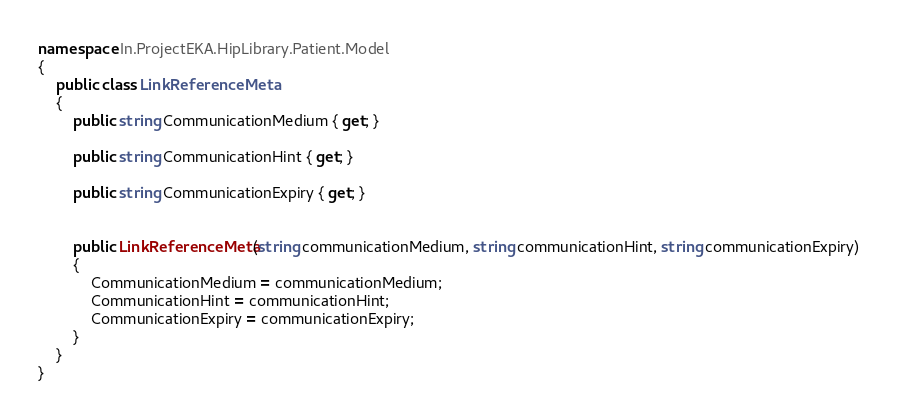<code> <loc_0><loc_0><loc_500><loc_500><_C#_>namespace In.ProjectEKA.HipLibrary.Patient.Model
{
    public class LinkReferenceMeta
    {
        public string CommunicationMedium { get; }

        public string CommunicationHint { get; }
        
        public string CommunicationExpiry { get; }


        public LinkReferenceMeta(string communicationMedium, string communicationHint, string communicationExpiry)
        {
            CommunicationMedium = communicationMedium;
            CommunicationHint = communicationHint;
            CommunicationExpiry = communicationExpiry;
        }
    }
}</code> 